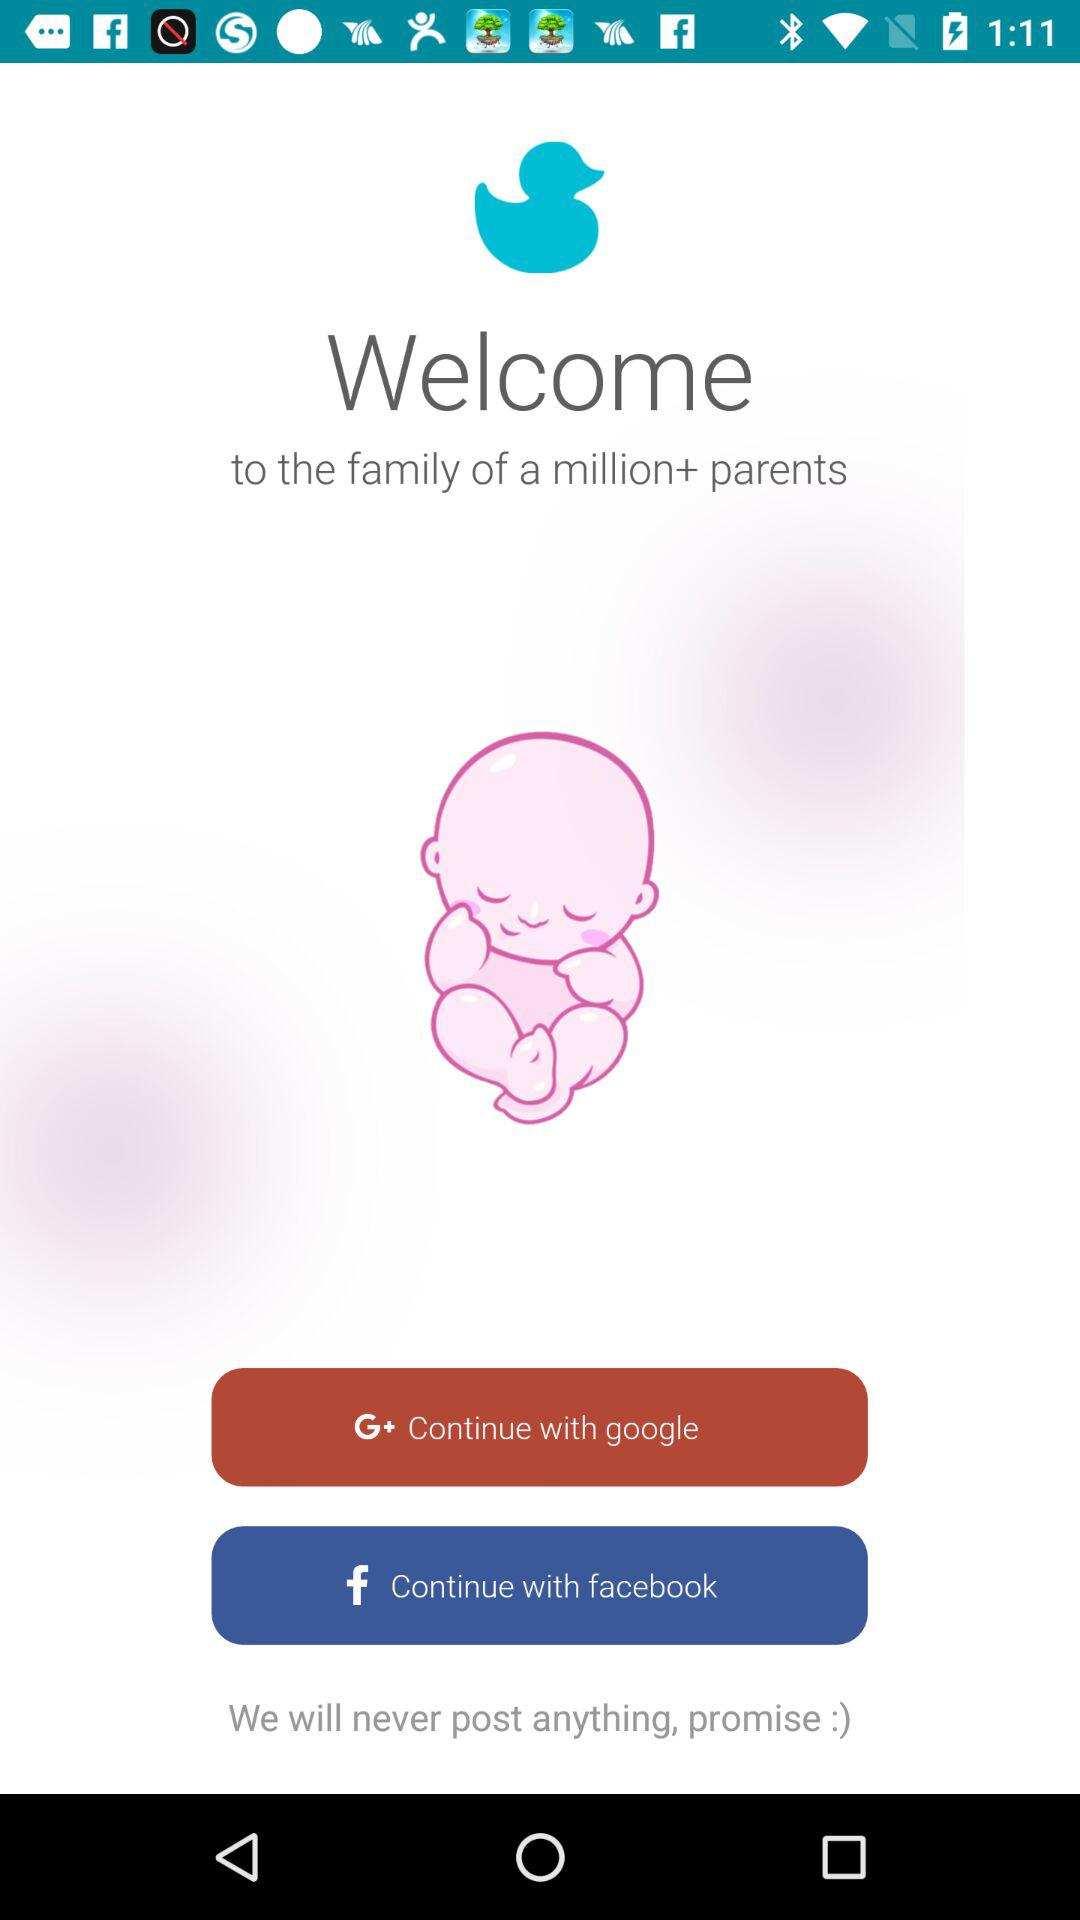How many rating stars does this application have?
When the provided information is insufficient, respond with <no answer>. <no answer> 